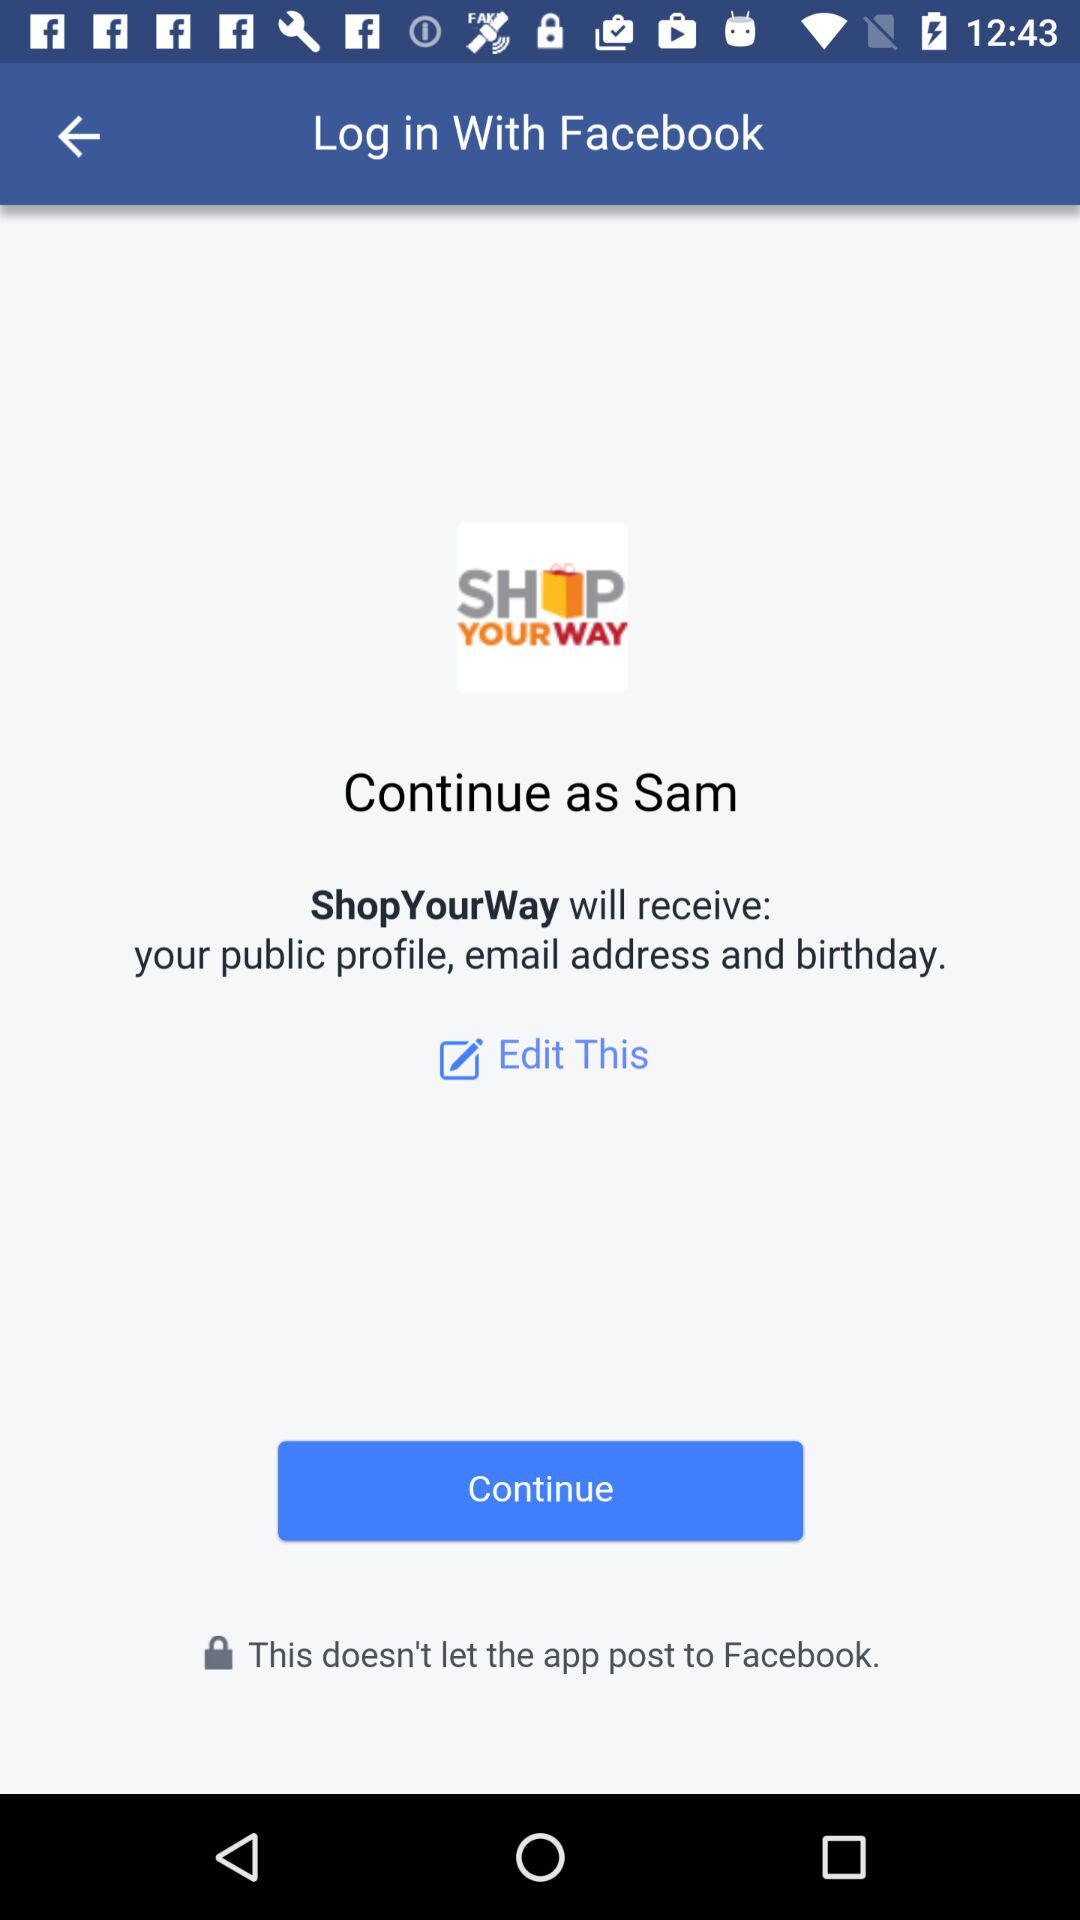What application is asking for permission? The application asking for permission is "ShopYourWay". 